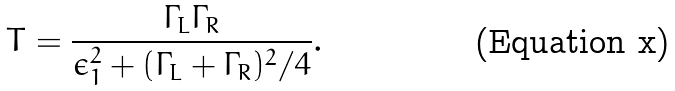Convert formula to latex. <formula><loc_0><loc_0><loc_500><loc_500>T = \frac { \Gamma _ { L } \Gamma _ { R } } { \epsilon _ { 1 } ^ { 2 } + ( \Gamma _ { L } + \Gamma _ { R } ) ^ { 2 } / 4 } .</formula> 